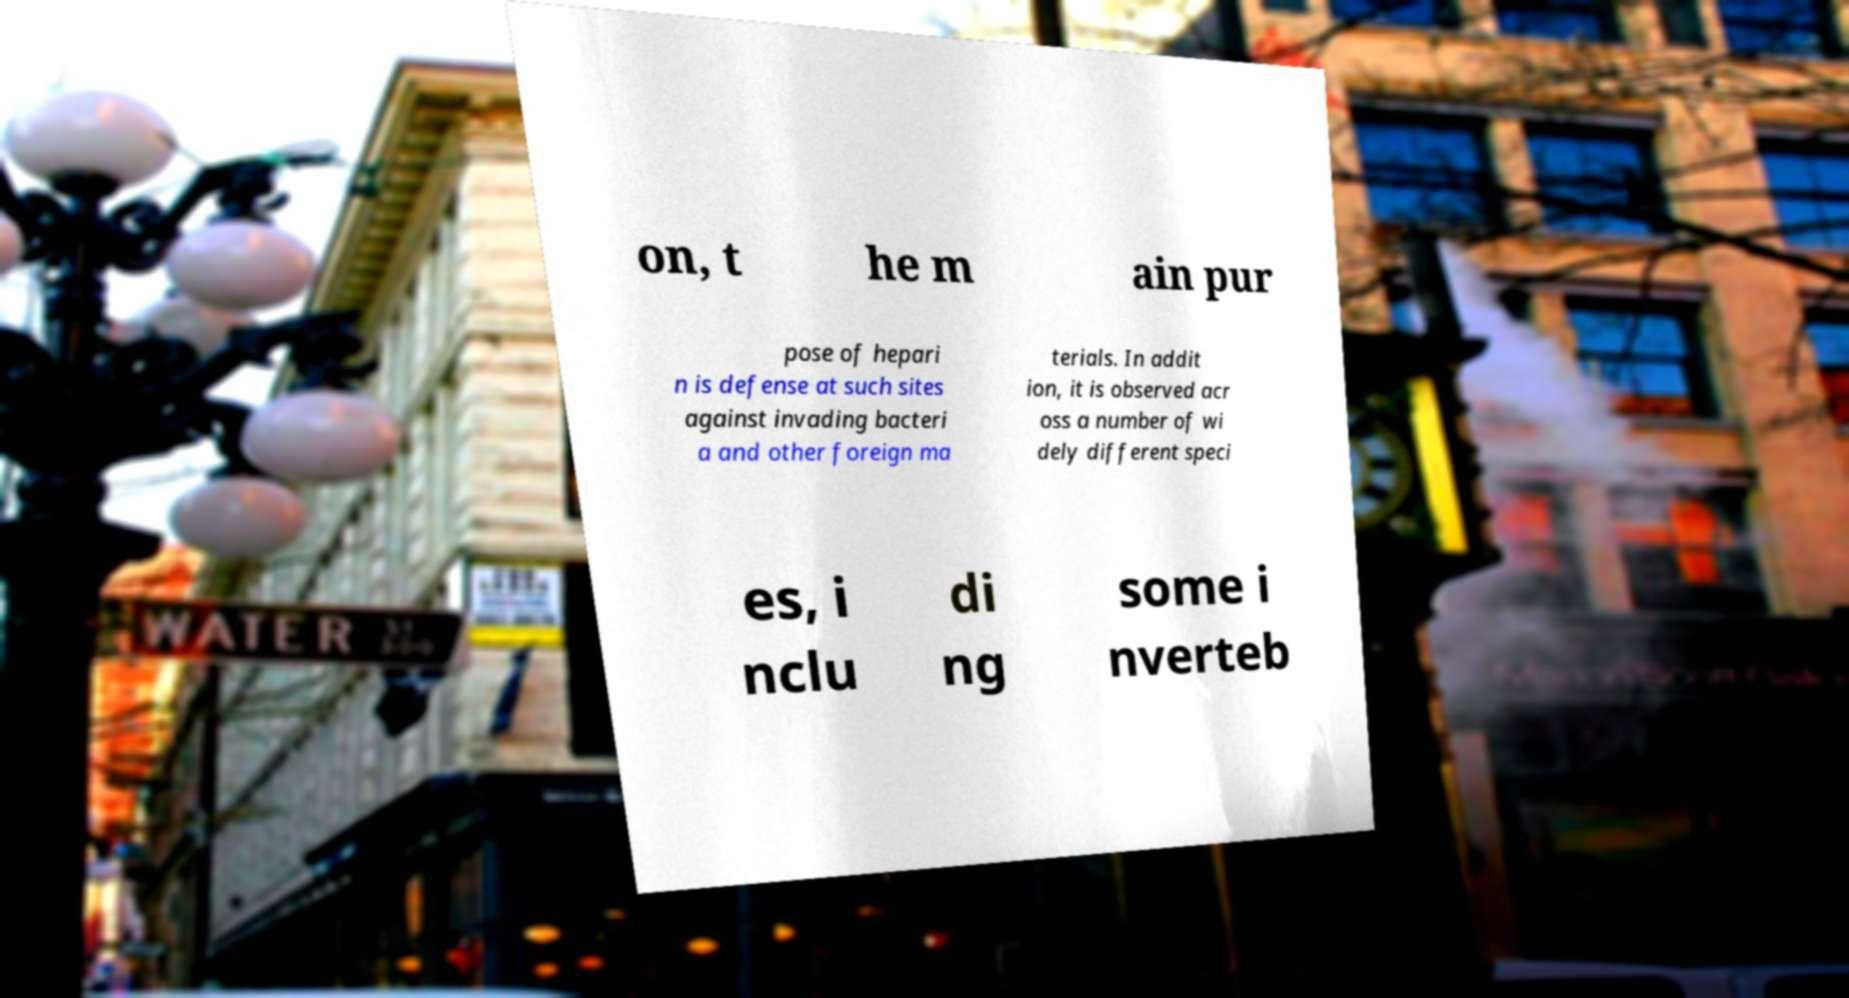For documentation purposes, I need the text within this image transcribed. Could you provide that? on, t he m ain pur pose of hepari n is defense at such sites against invading bacteri a and other foreign ma terials. In addit ion, it is observed acr oss a number of wi dely different speci es, i nclu di ng some i nverteb 